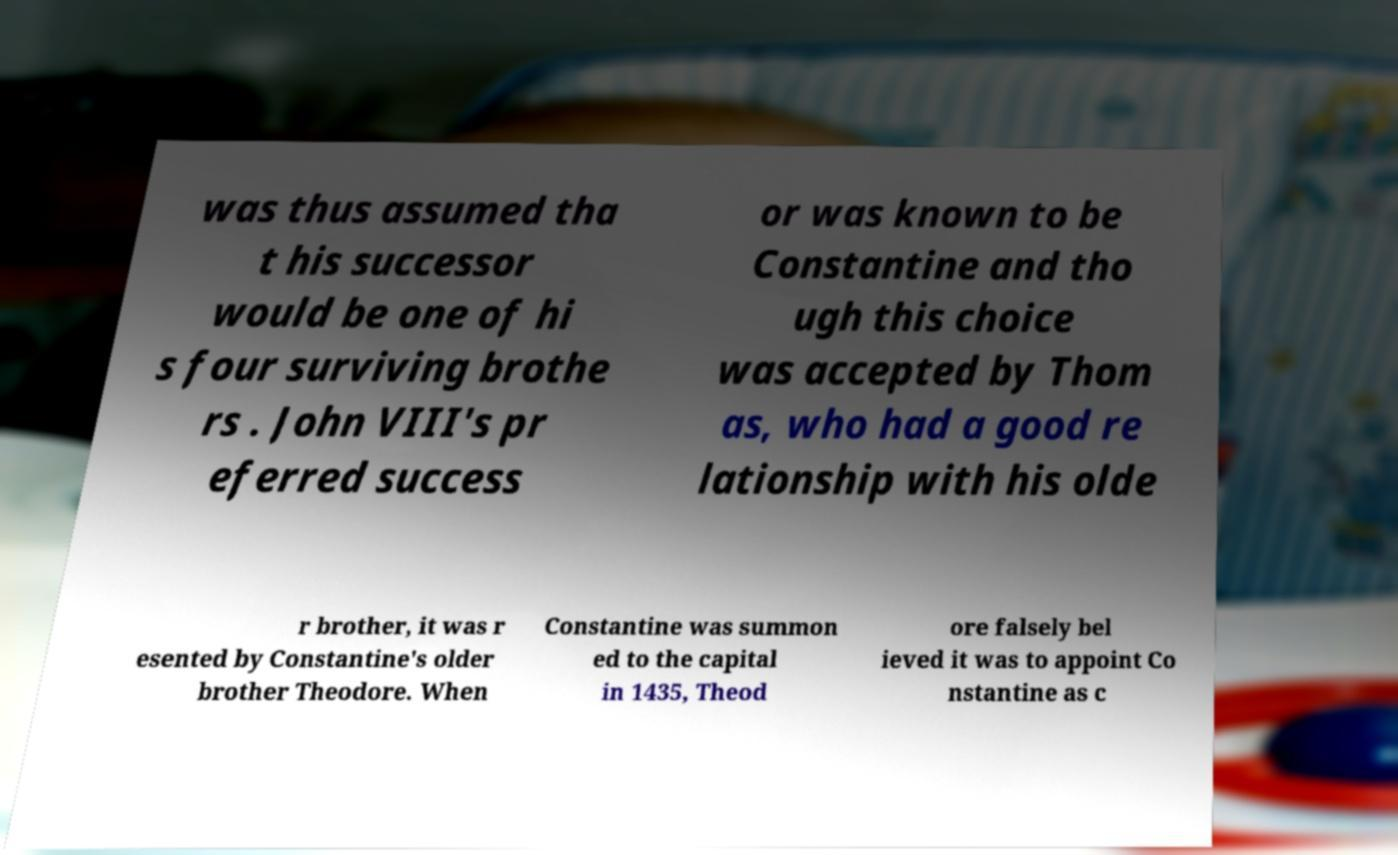Please identify and transcribe the text found in this image. was thus assumed tha t his successor would be one of hi s four surviving brothe rs . John VIII's pr eferred success or was known to be Constantine and tho ugh this choice was accepted by Thom as, who had a good re lationship with his olde r brother, it was r esented by Constantine's older brother Theodore. When Constantine was summon ed to the capital in 1435, Theod ore falsely bel ieved it was to appoint Co nstantine as c 